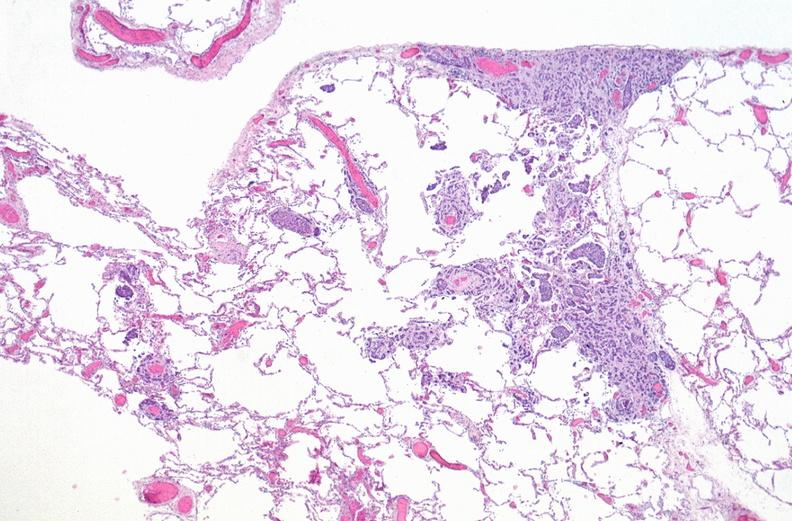what does this image show?
Answer the question using a single word or phrase. Breast cancer metastasis to lung 